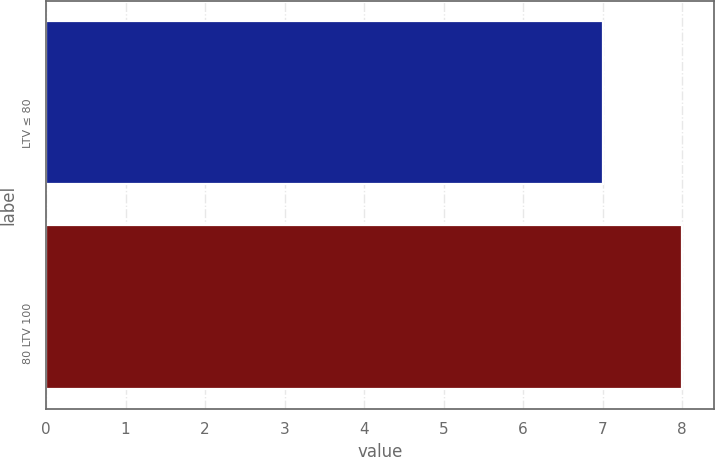<chart> <loc_0><loc_0><loc_500><loc_500><bar_chart><fcel>LTV ≤ 80<fcel>80 LTV 100<nl><fcel>7<fcel>8<nl></chart> 